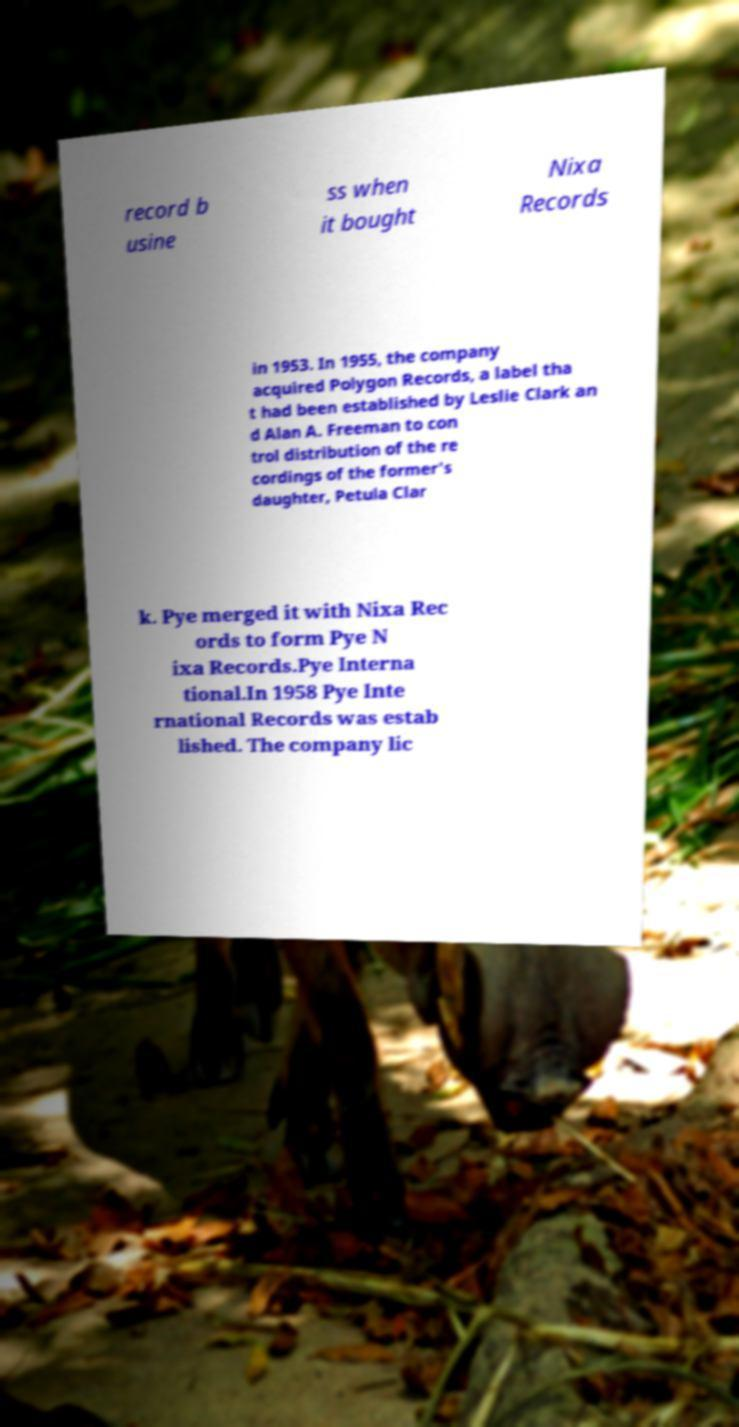Could you extract and type out the text from this image? record b usine ss when it bought Nixa Records in 1953. In 1955, the company acquired Polygon Records, a label tha t had been established by Leslie Clark an d Alan A. Freeman to con trol distribution of the re cordings of the former's daughter, Petula Clar k. Pye merged it with Nixa Rec ords to form Pye N ixa Records.Pye Interna tional.In 1958 Pye Inte rnational Records was estab lished. The company lic 